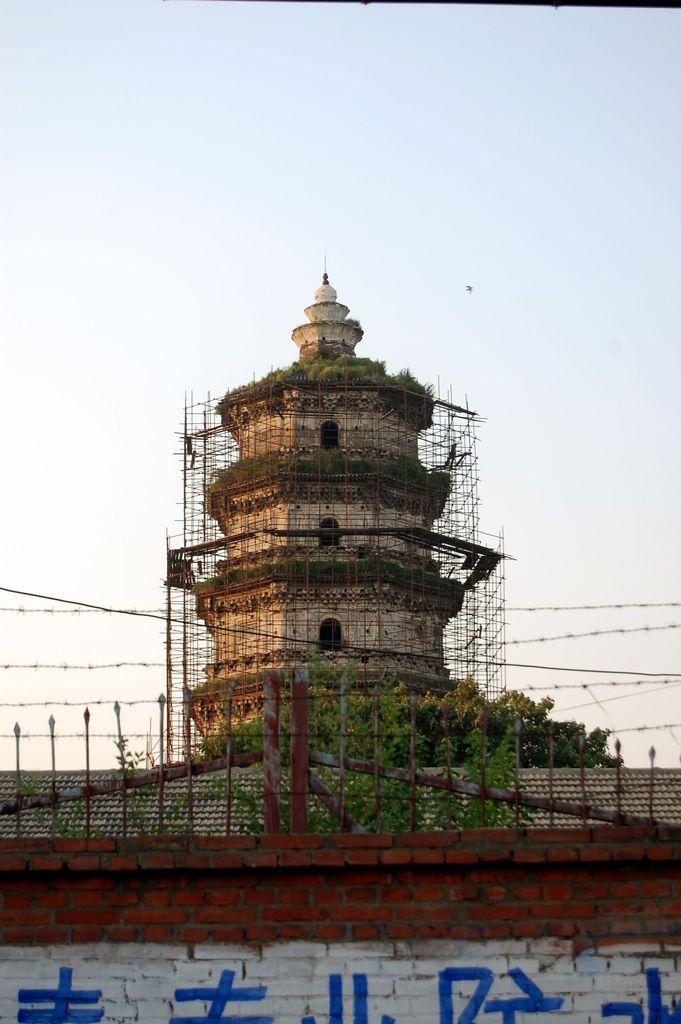What type of structure can be seen in the image? There are iron grills in the image. What else is present in the image besides the iron grills? There is a wall, trees, a building under construction, and the sky is visible in the background of the image. Can you describe the building in the image? The building is under construction. What can be seen in the sky in the image? The sky is visible in the background of the image. What religious symbol can be seen on the iron grills in the image? There is no religious symbol present on the iron grills in the image. What humorous element is included in the image? There is no humorous element present in the image. What discovery was made at the construction site in the image? There is no mention of a discovery made at the construction site in the image. 